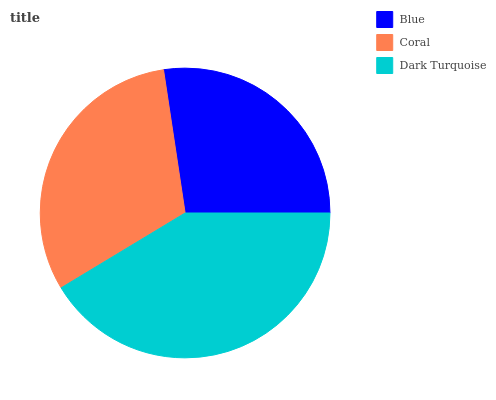Is Blue the minimum?
Answer yes or no. Yes. Is Dark Turquoise the maximum?
Answer yes or no. Yes. Is Coral the minimum?
Answer yes or no. No. Is Coral the maximum?
Answer yes or no. No. Is Coral greater than Blue?
Answer yes or no. Yes. Is Blue less than Coral?
Answer yes or no. Yes. Is Blue greater than Coral?
Answer yes or no. No. Is Coral less than Blue?
Answer yes or no. No. Is Coral the high median?
Answer yes or no. Yes. Is Coral the low median?
Answer yes or no. Yes. Is Dark Turquoise the high median?
Answer yes or no. No. Is Dark Turquoise the low median?
Answer yes or no. No. 